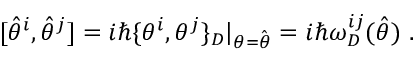<formula> <loc_0><loc_0><loc_500><loc_500>[ \hat { \theta } ^ { i } , \hat { \theta } ^ { j } ] = i \hbar { \{ } \theta ^ { i } , \theta ^ { j } \} _ { D } | _ { \theta = \hat { \theta } } = i \hbar { \omega } _ { D } ^ { i j } ( \hat { \theta } ) \ .</formula> 